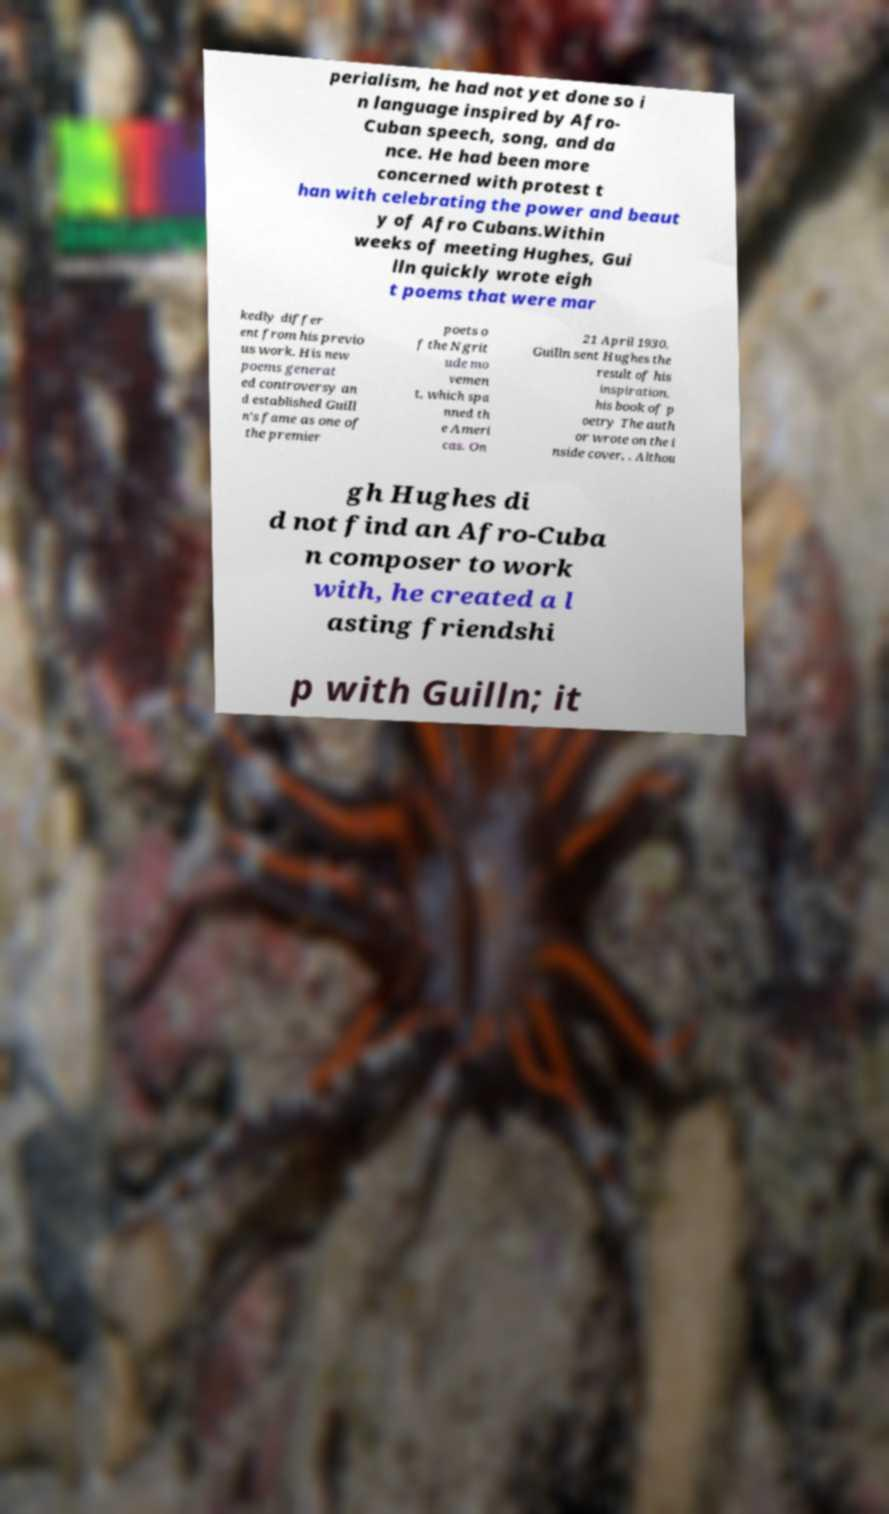Can you accurately transcribe the text from the provided image for me? perialism, he had not yet done so i n language inspired by Afro- Cuban speech, song, and da nce. He had been more concerned with protest t han with celebrating the power and beaut y of Afro Cubans.Within weeks of meeting Hughes, Gui lln quickly wrote eigh t poems that were mar kedly differ ent from his previo us work. His new poems generat ed controversy an d established Guill n's fame as one of the premier poets o f the Ngrit ude mo vemen t, which spa nned th e Ameri cas. On 21 April 1930, Guilln sent Hughes the result of his inspiration, his book of p oetry The auth or wrote on the i nside cover, . Althou gh Hughes di d not find an Afro-Cuba n composer to work with, he created a l asting friendshi p with Guilln; it 